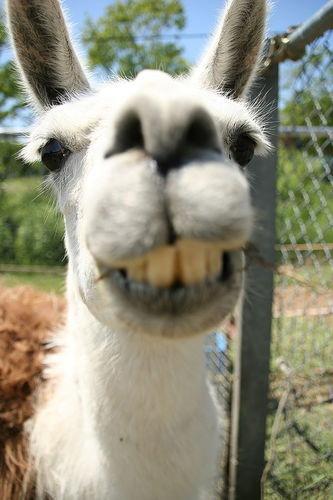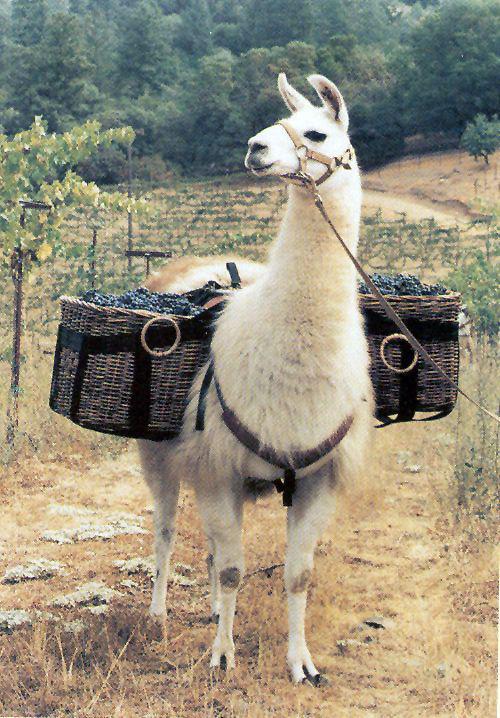The first image is the image on the left, the second image is the image on the right. For the images shown, is this caption "Something is wearing pink." true? Answer yes or no. No. The first image is the image on the left, the second image is the image on the right. Assess this claim about the two images: "At least one person can be seen holding reins.". Correct or not? Answer yes or no. No. 